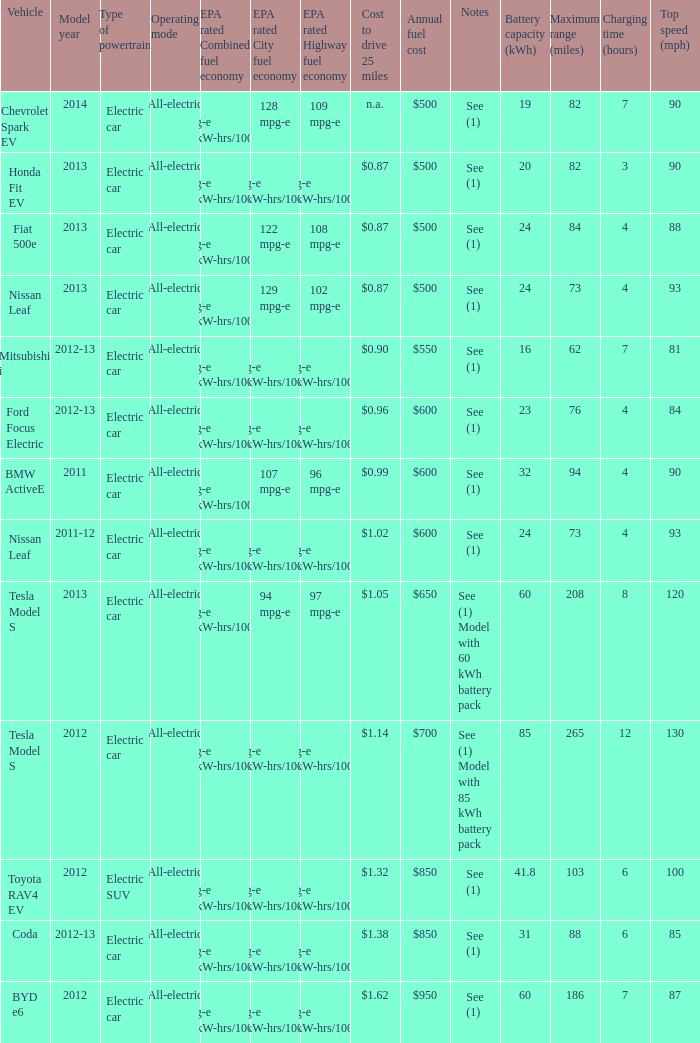What is the epa highway fuel economy for an electric suv? 74 mpg-e (46kW-hrs/100mi). 